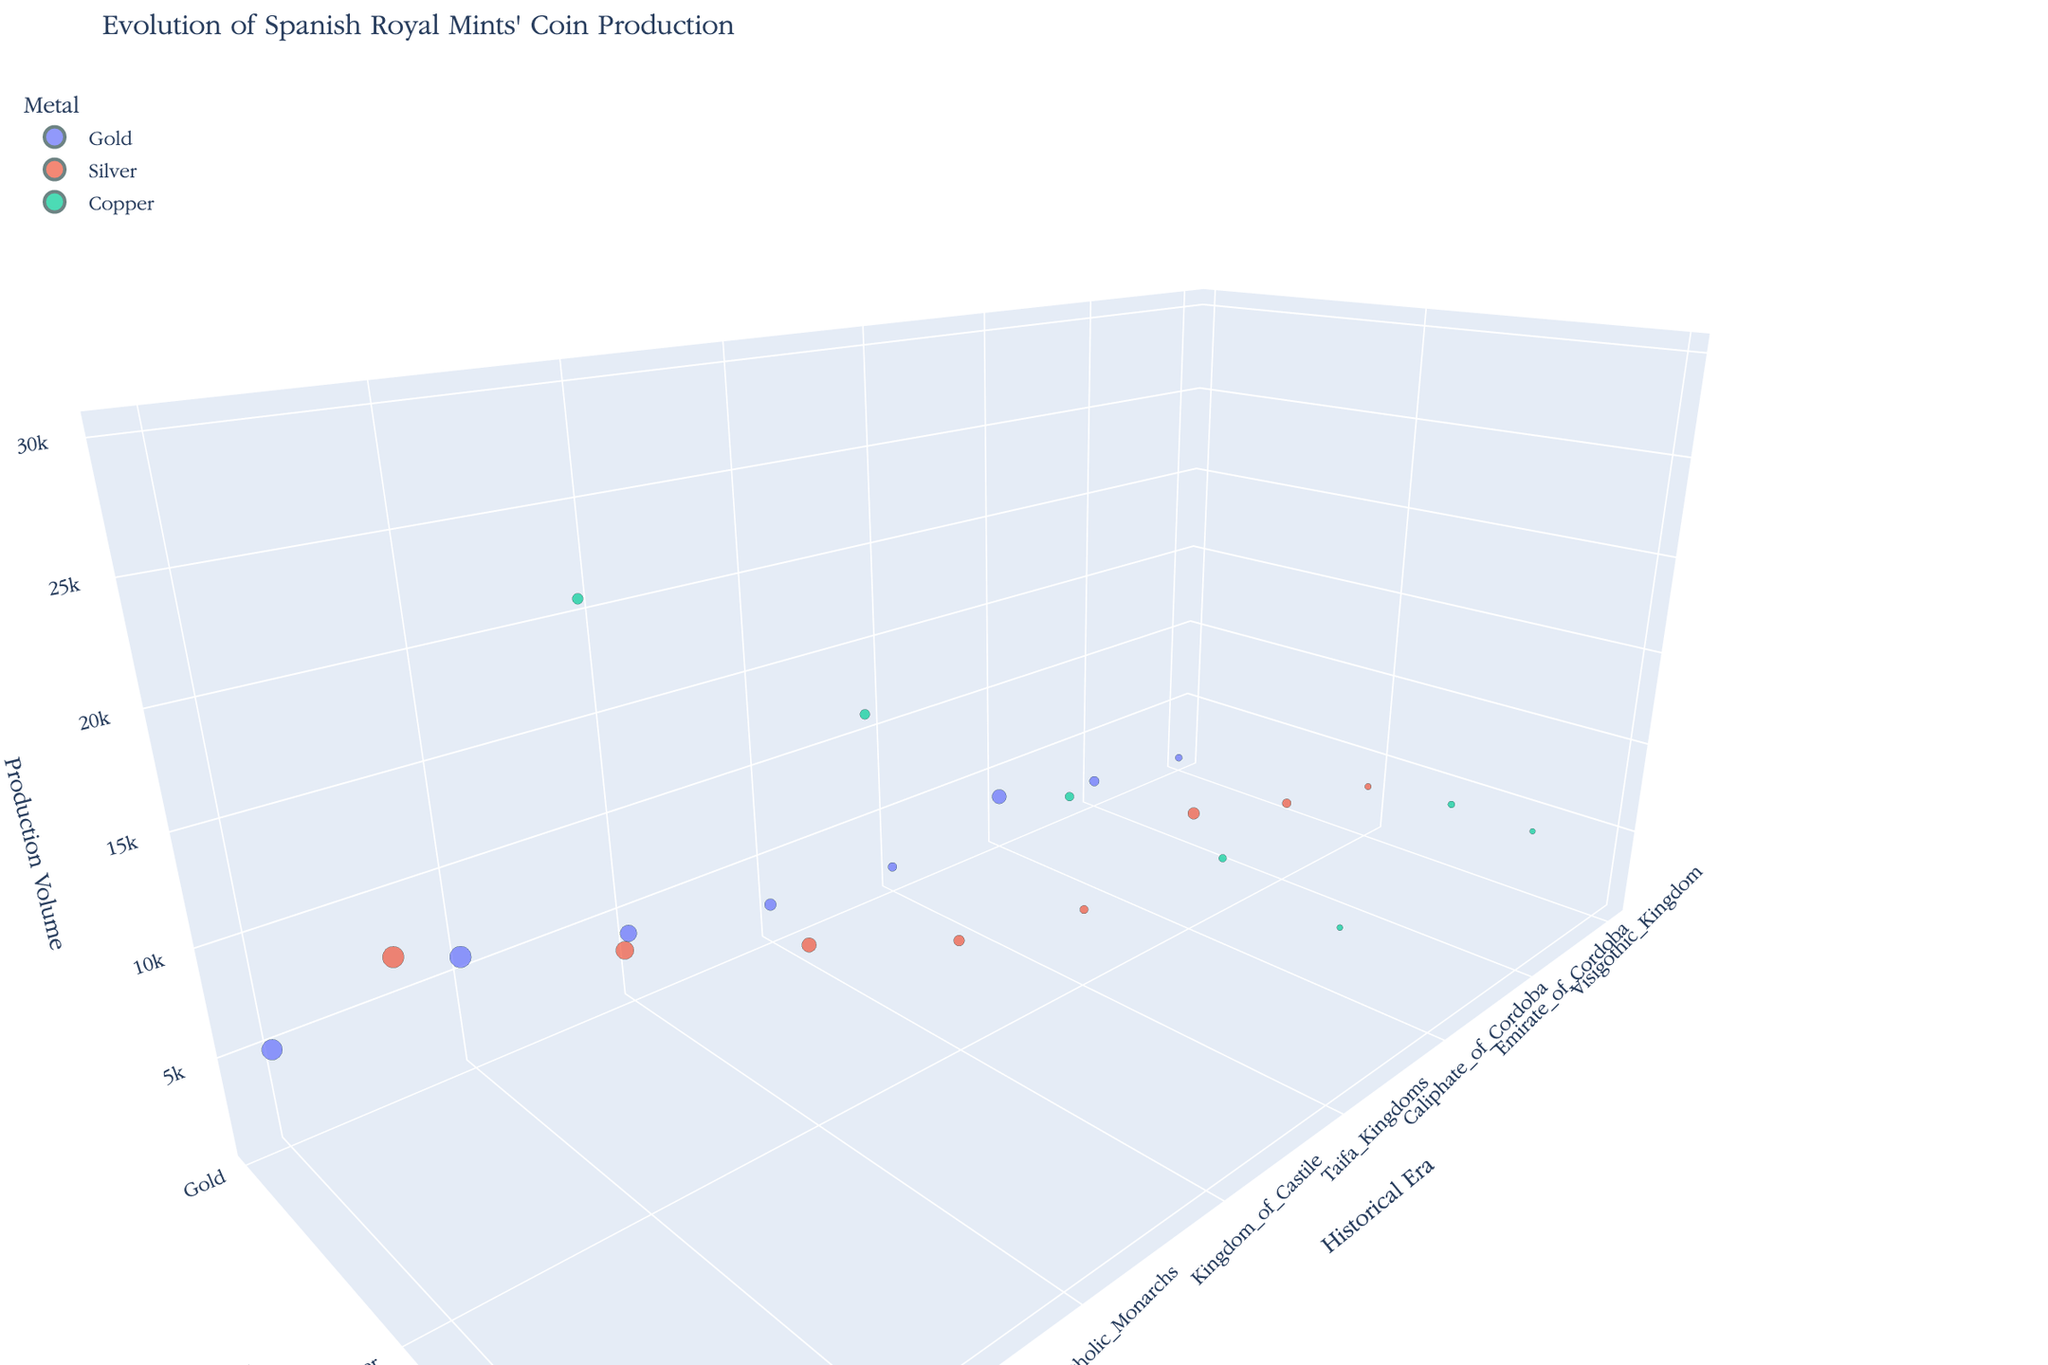What's the title of the chart? The title of the chart is usually displayed at the top of the visualization. By looking at the figure, you can find that the title is "Evolution of Spanish Royal Mints' Coin Production".
Answer: Evolution of Spanish Royal Mints' Coin Production What are the labels of the axes? The labels of the axes are displayed on the 3D chart. The x-axis (horizontal) is labeled 'Historical Era', the y-axis (vertical) is labeled 'Metal Type', and the z-axis (depth) is labeled 'Production Volume'.
Answer: Historical Era, Metal Type, Production Volume Which era has the highest production volume in gold coins? To find this, locate the 'Gold' category in the 'Metal Type' axis and compare the 'Production Volume' along the z-axis for each era. The highest production volume for gold is during 'Habsburg Spain'.
Answer: Habsburg Spain During which era do silver coins have the highest total value? Determine this by looking at the size of the bubbles for the 'Silver' metal. The largest bubble for silver, indicating the highest total value, is during 'Bourbon Spain'.
Answer: Bourbon Spain Compare the production volumes of copper coins between Caliphate of Cordoba and Catholic Monarchs. Which era had a higher production? To compare, look at the z-axis values for 'Copper' in both the 'Caliphate of Cordoba' and 'Catholic Monarchs' eras. 'Catholic Monarchs' has a higher production volume than the 'Caliphate of Cordoba'.
Answer: Catholic Monarchs Which metal type had the lowest production volume in the Visigothic Kingdom era? Look at the 'Visigothic Kingdom' era and compare the bubbles for each metal. The 'Gold' category has the smallest bubble, indicating the lowest production volume.
Answer: Gold How does the production volume of silver coins in the Emirate of Cordoba compare to that in the Kingdom of Castile? Locate the 'Silver' metal type and compare the z-axis values for 'Emirate of Cordoba' and 'Kingdom of Castile'. The production volume is higher during the 'Kingdom of Castile'.
Answer: Kingdom of Castile What’s the average production volume of gold coins over all historical eras? First, list the production volumes of gold coins from each era: 1200, 2000, 3500, 1800, 2500, 4000, 6000, 5000. Sum them up (1200 + 2000 + 3500 + 1800 + 2500 + 4000 + 6000 + 5000 = 26000) and then divide by the number of points (8). So, 26000 / 8 = 3250.
Answer: 3250 Identify the era with the smallest bubble for copper coins. Find the smallest bubble size for the copper metal type across all eras. The smallest bubble for copper is in the 'Emirate of Cordoba'.
Answer: Emirate of Cordoba 